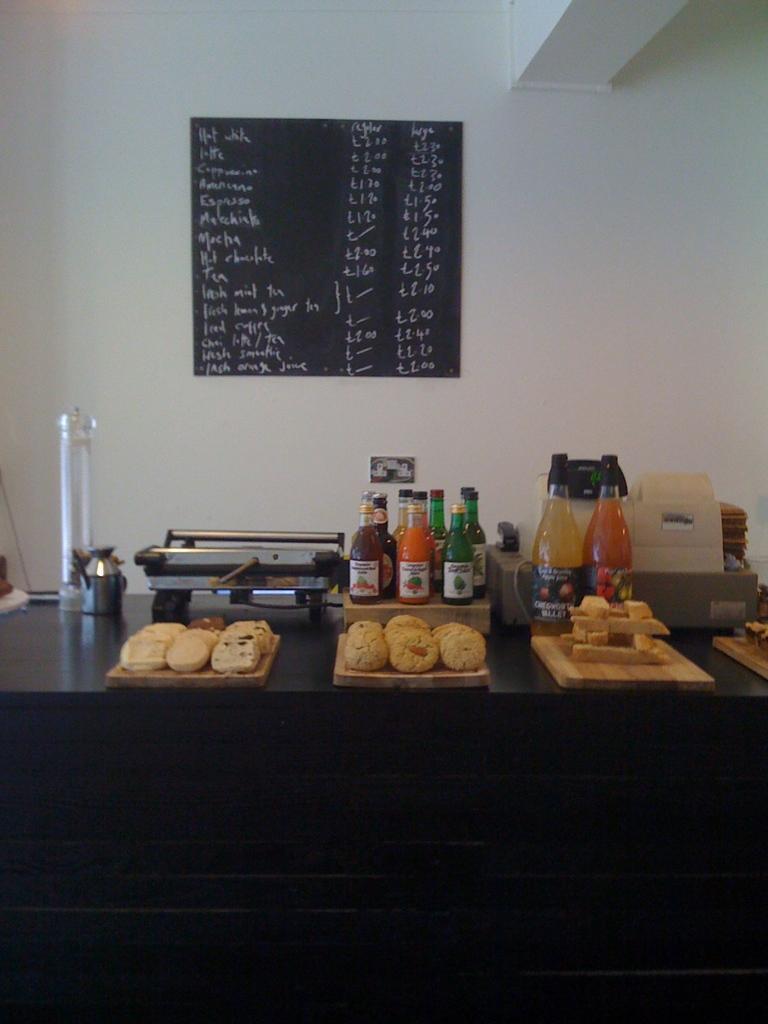In one or two sentences, can you explain what this image depicts? On this table there is a food in tray, bottles and machine. Blackboard on wall. 